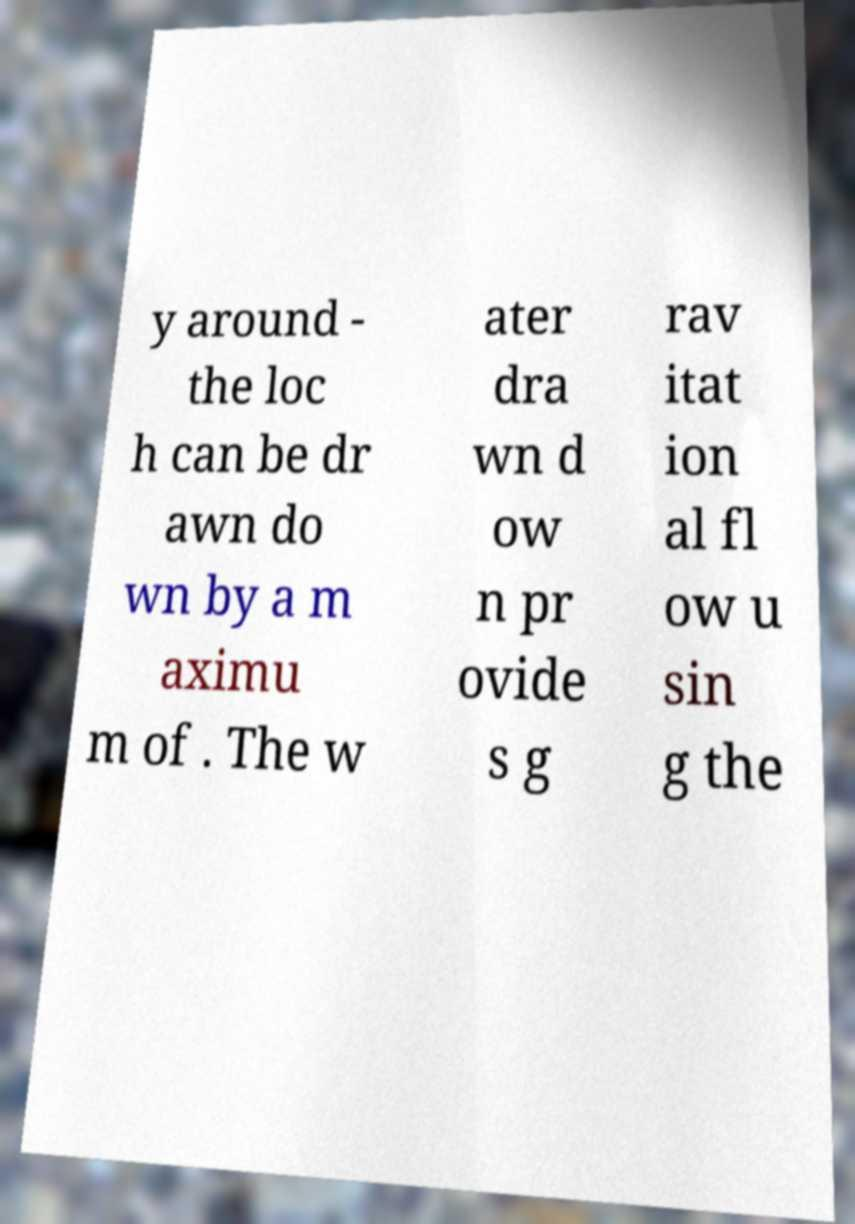What messages or text are displayed in this image? I need them in a readable, typed format. y around - the loc h can be dr awn do wn by a m aximu m of . The w ater dra wn d ow n pr ovide s g rav itat ion al fl ow u sin g the 